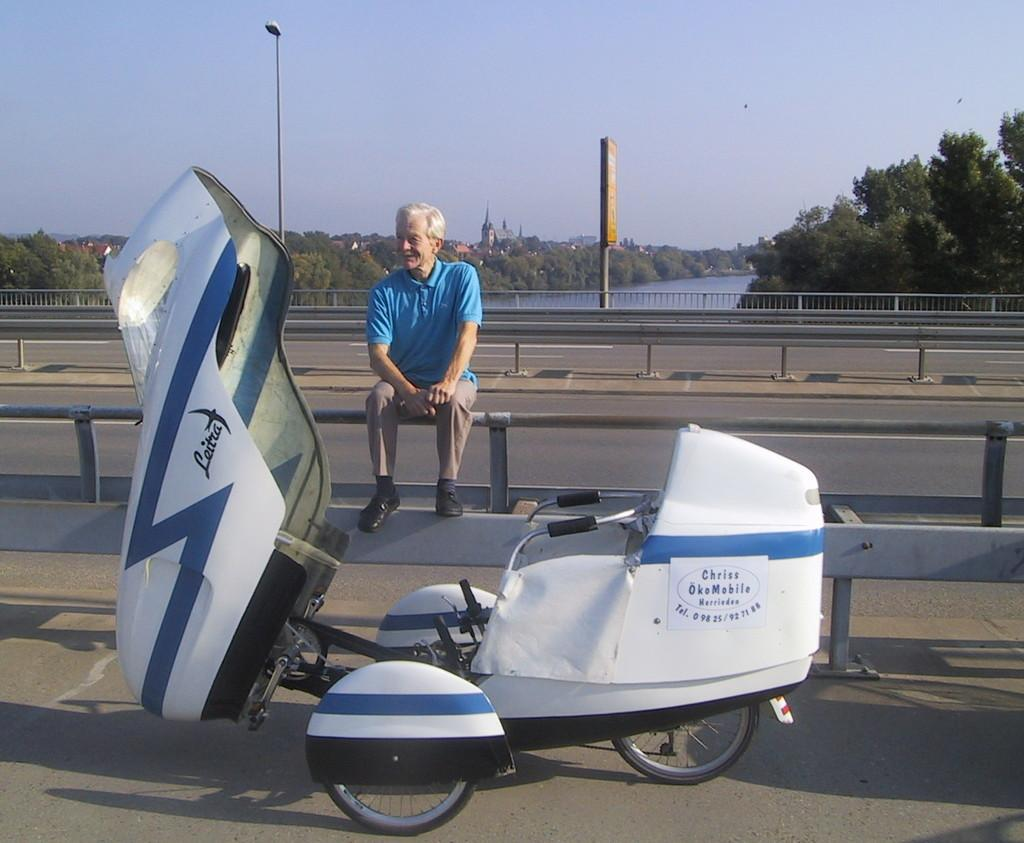<image>
Share a concise interpretation of the image provided. A Leitra motorized vehicle is stopped with the front opened as a man sits on a railing beside. it. 